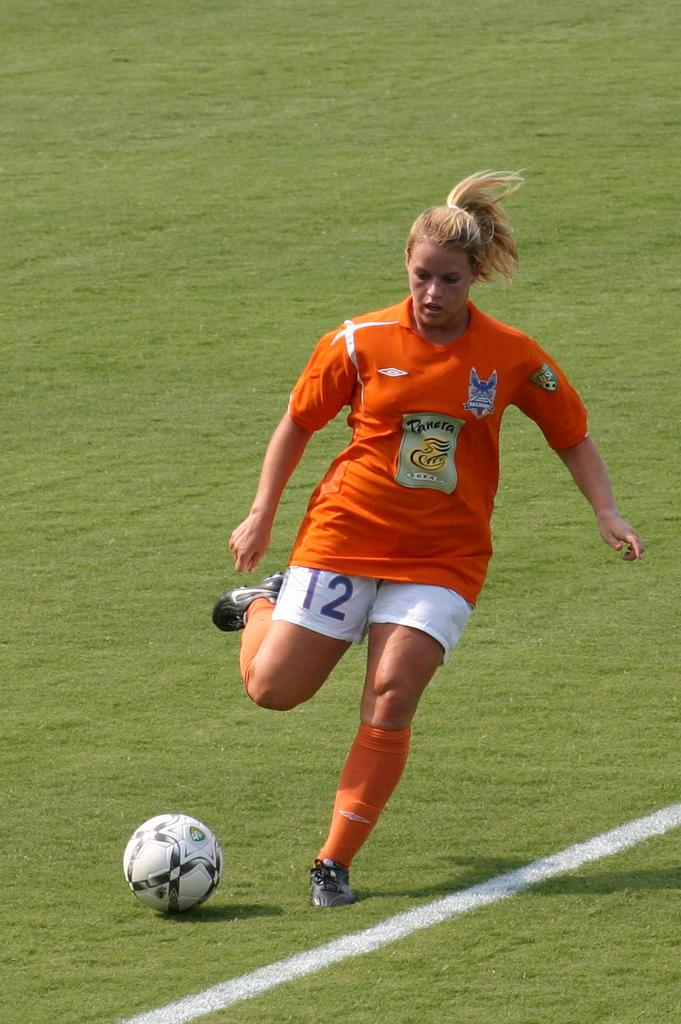Who is the main subject in the picture? There is a woman in the picture. What is the woman wearing? The woman is wearing an orange T-shirt. What is the ground like where the woman is standing? The woman is standing on a greenery ground. What is the woman doing with her legs? The woman has one leg lifted off the ground. What object can be seen in front of the woman? There is a ball in front of the woman. What type of egg can be seen balancing on the needle in the image? There is no egg or needle present in the image; it features a woman standing on a greenery ground with a ball in front of her. 